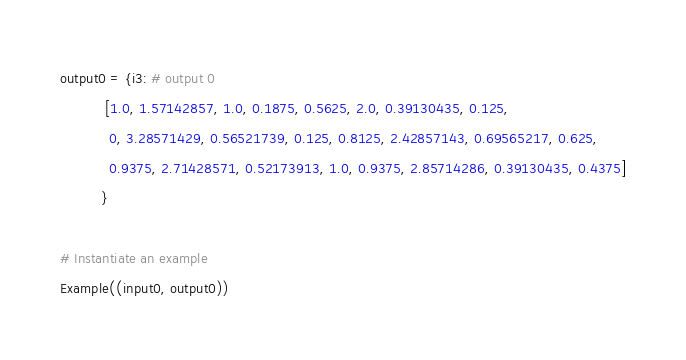Convert code to text. <code><loc_0><loc_0><loc_500><loc_500><_Python_>
output0 = {i3: # output 0
           [1.0, 1.57142857, 1.0, 0.1875, 0.5625, 2.0, 0.39130435, 0.125,
            0, 3.28571429, 0.56521739, 0.125, 0.8125, 2.42857143, 0.69565217, 0.625,
            0.9375, 2.71428571, 0.52173913, 1.0, 0.9375, 2.85714286, 0.39130435, 0.4375]
          }

# Instantiate an example
Example((input0, output0))
</code> 